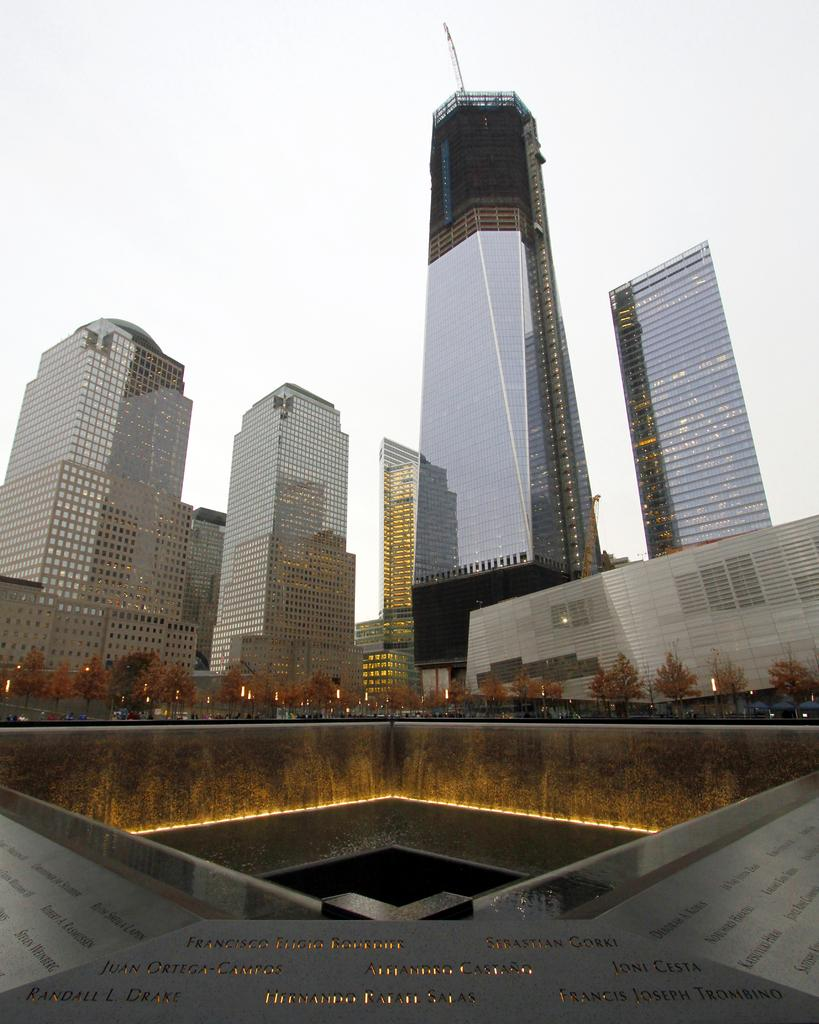What type of structures can be seen in the image? There are multiple buildings in the image. Can you describe any additional features in the image? Yes, there are lights visible in the image. How many clams are present in the image? There are no clams present in the image. What color is the mailbox in the image? There is no mailbox present in the image. 